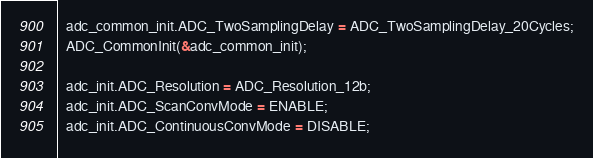<code> <loc_0><loc_0><loc_500><loc_500><_C++_>  adc_common_init.ADC_TwoSamplingDelay = ADC_TwoSamplingDelay_20Cycles;
  ADC_CommonInit(&adc_common_init);
  
  adc_init.ADC_Resolution = ADC_Resolution_12b;
  adc_init.ADC_ScanConvMode = ENABLE;
  adc_init.ADC_ContinuousConvMode = DISABLE;</code> 